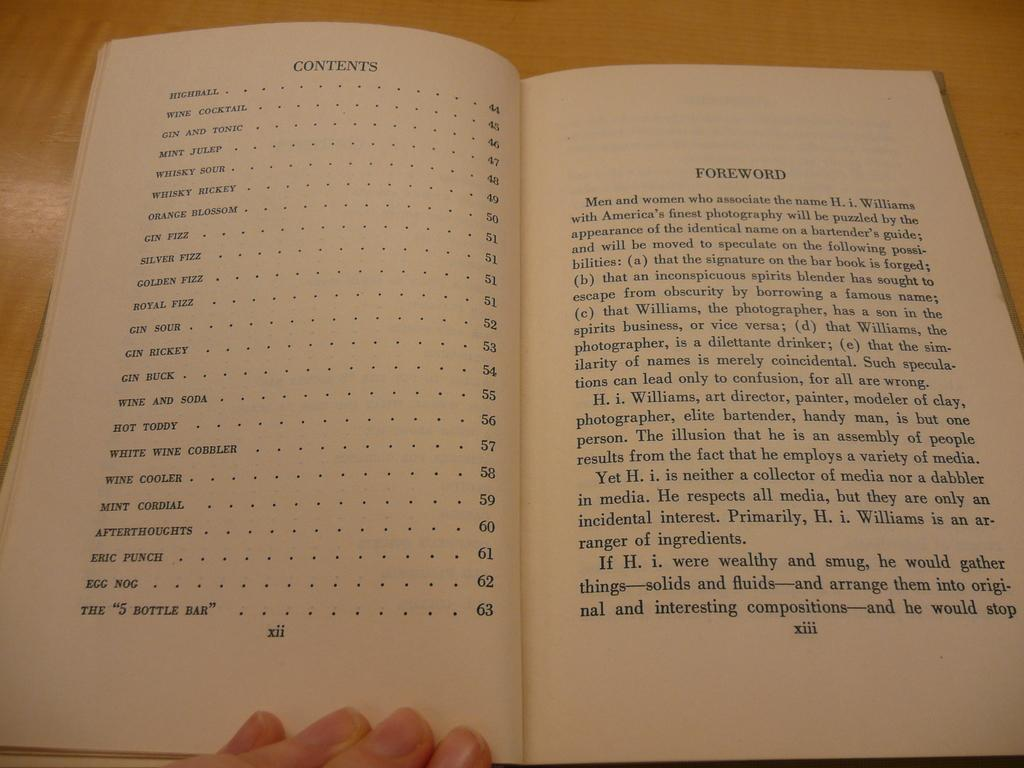<image>
Offer a succinct explanation of the picture presented. two book pages one listing contents and the other the foreword 